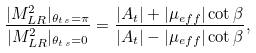Convert formula to latex. <formula><loc_0><loc_0><loc_500><loc_500>\frac { | M _ { L R } ^ { 2 } | _ { \theta _ { t \, s } = \pi } } { | M _ { L R } ^ { 2 } | _ { \theta _ { t \, s } = 0 } } = \frac { | A _ { t } | + | \mu _ { e f f } | \cot \beta } { | A _ { t } | - | \mu _ { e f f } | \cot \beta } ,</formula> 